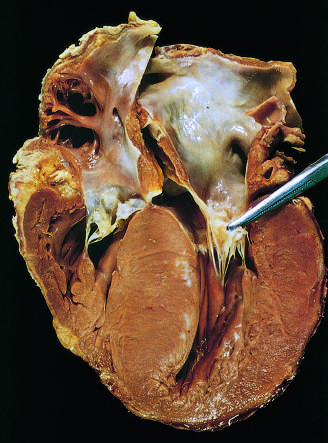has low-power view of a cross section of a skin blister showing the epidermis been moved away from the septum to reveal a fibrous endocardial plaque see text?
Answer the question using a single word or phrase. No 